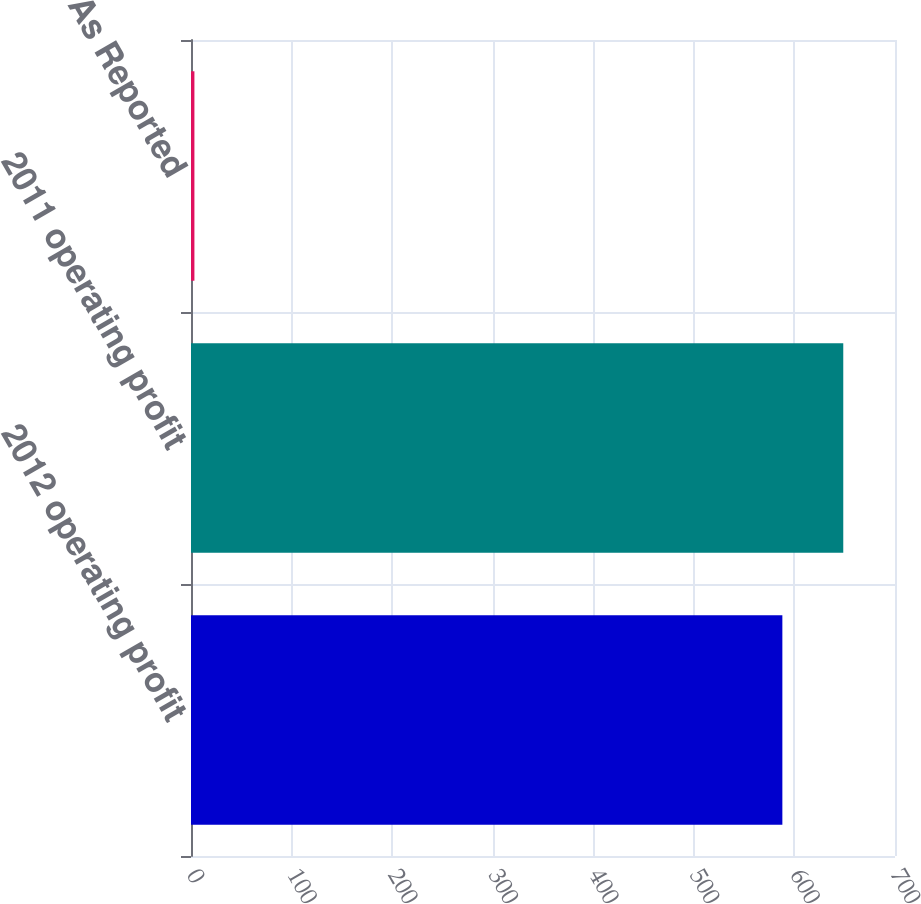<chart> <loc_0><loc_0><loc_500><loc_500><bar_chart><fcel>2012 operating profit<fcel>2011 operating profit<fcel>As Reported<nl><fcel>588<fcel>648.56<fcel>3.4<nl></chart> 